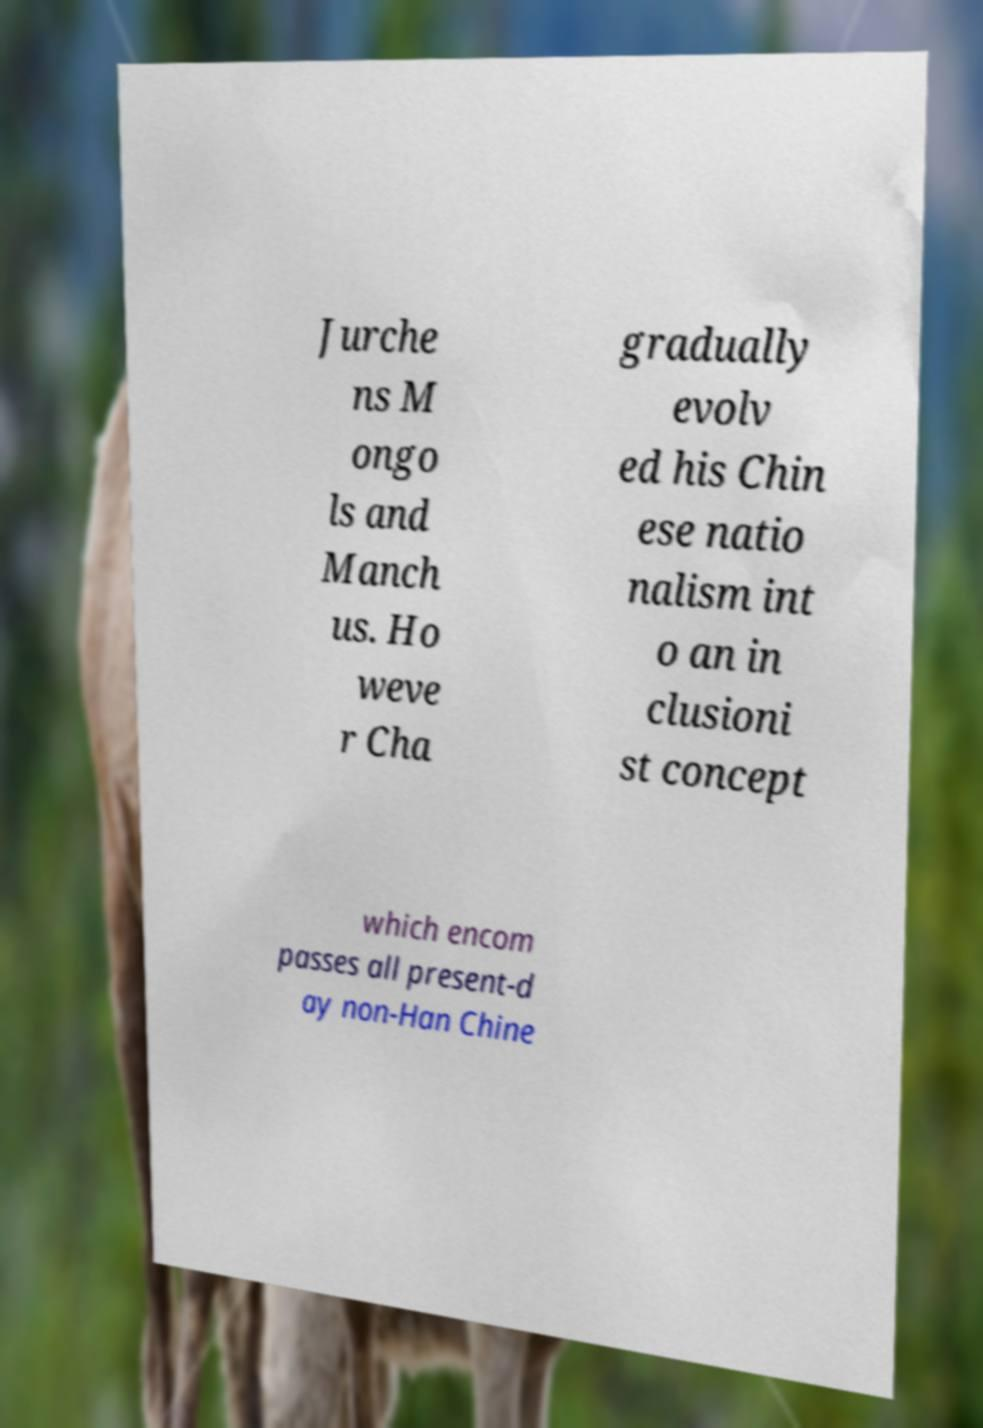Please identify and transcribe the text found in this image. Jurche ns M ongo ls and Manch us. Ho weve r Cha gradually evolv ed his Chin ese natio nalism int o an in clusioni st concept which encom passes all present-d ay non-Han Chine 